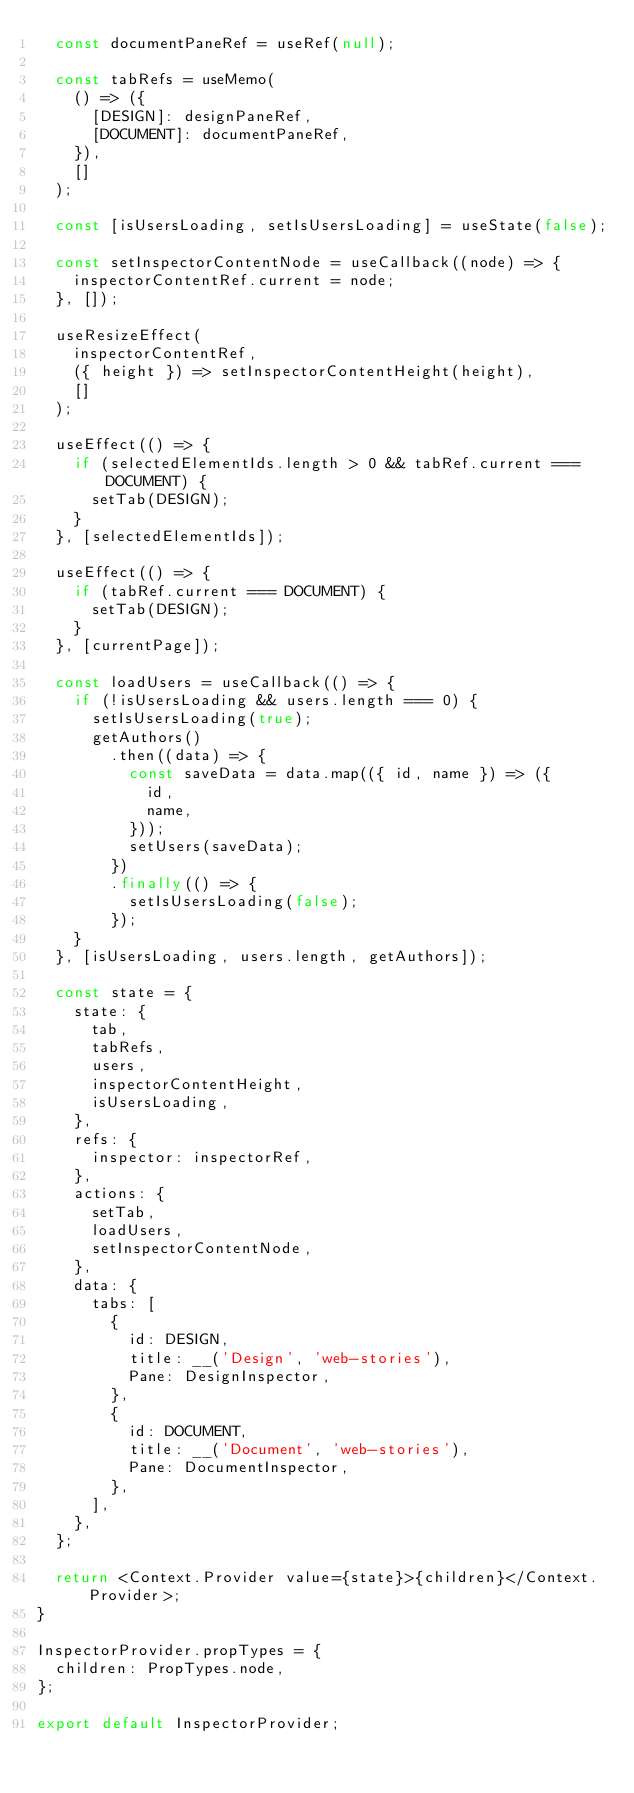Convert code to text. <code><loc_0><loc_0><loc_500><loc_500><_JavaScript_>  const documentPaneRef = useRef(null);

  const tabRefs = useMemo(
    () => ({
      [DESIGN]: designPaneRef,
      [DOCUMENT]: documentPaneRef,
    }),
    []
  );

  const [isUsersLoading, setIsUsersLoading] = useState(false);

  const setInspectorContentNode = useCallback((node) => {
    inspectorContentRef.current = node;
  }, []);

  useResizeEffect(
    inspectorContentRef,
    ({ height }) => setInspectorContentHeight(height),
    []
  );

  useEffect(() => {
    if (selectedElementIds.length > 0 && tabRef.current === DOCUMENT) {
      setTab(DESIGN);
    }
  }, [selectedElementIds]);

  useEffect(() => {
    if (tabRef.current === DOCUMENT) {
      setTab(DESIGN);
    }
  }, [currentPage]);

  const loadUsers = useCallback(() => {
    if (!isUsersLoading && users.length === 0) {
      setIsUsersLoading(true);
      getAuthors()
        .then((data) => {
          const saveData = data.map(({ id, name }) => ({
            id,
            name,
          }));
          setUsers(saveData);
        })
        .finally(() => {
          setIsUsersLoading(false);
        });
    }
  }, [isUsersLoading, users.length, getAuthors]);

  const state = {
    state: {
      tab,
      tabRefs,
      users,
      inspectorContentHeight,
      isUsersLoading,
    },
    refs: {
      inspector: inspectorRef,
    },
    actions: {
      setTab,
      loadUsers,
      setInspectorContentNode,
    },
    data: {
      tabs: [
        {
          id: DESIGN,
          title: __('Design', 'web-stories'),
          Pane: DesignInspector,
        },
        {
          id: DOCUMENT,
          title: __('Document', 'web-stories'),
          Pane: DocumentInspector,
        },
      ],
    },
  };

  return <Context.Provider value={state}>{children}</Context.Provider>;
}

InspectorProvider.propTypes = {
  children: PropTypes.node,
};

export default InspectorProvider;
</code> 